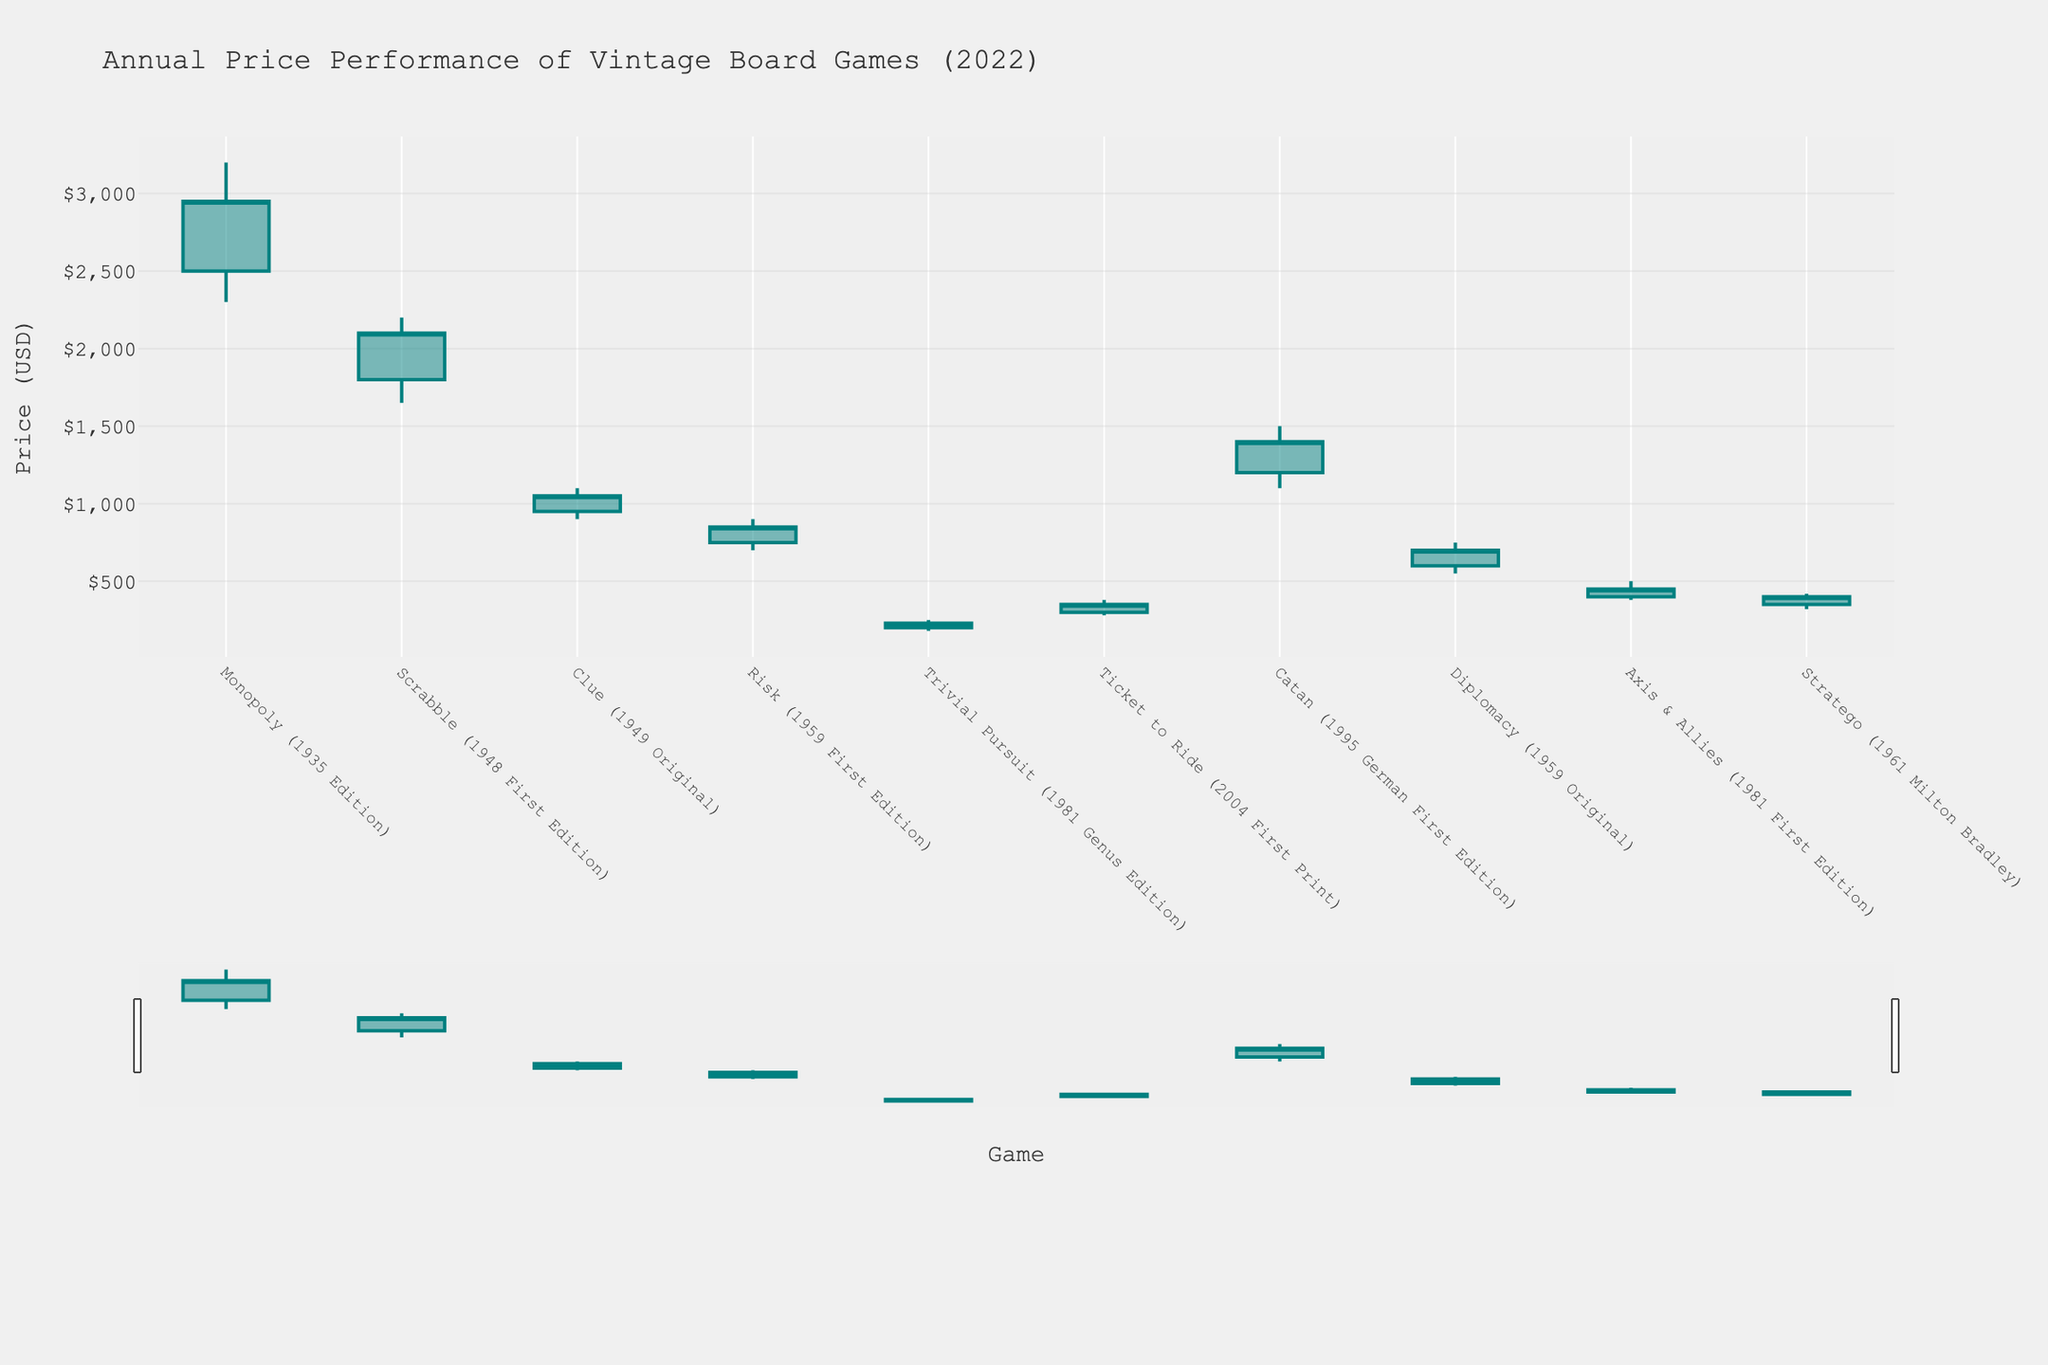What's the title of the figure? The title is located at the top of the figure, providing a concise description of what the data represents.
Answer: Annual Price Performance of Vintage Board Games (2022) How many board games are displayed in the figure? Count the number of distinct games listed on the x-axis.
Answer: 10 Which board game had the highest peak value in 2022? Locate the board game with the highest 'High' value by comparing peak values of all games.
Answer: Monopoly (1935 Edition) Which board game experienced the lowest value in 2022 and what was its lowest value? Find the game with the lowest 'Low' value by checking the 'Low' points of each game.
Answer: Trivial Pursuit (1981 Genus Edition), $180 What was the closing value of Catan (1995 German First Edition) in 2022? Identify Catan on the x-axis and refer to its 'Close' value.
Answer: $1400 Compare the opening and closing prices of Scrabble (1948 First Edition). Did the price increase or decrease? Check the 'Open' and 'Close' values for Scrabble and determine the difference.
Answer: Increased Which game had the smallest difference between its peak value and lowest value in 2022? For each game, calculate the difference between 'High' and 'Low' values and find the smallest difference.
Answer: Clue (1949 Original) What is the average closing value of all the board games displayed? Sum the 'Close' values of all games and divide by the number of games.
Answer: 1138.0 Among the games listed, which one had the highest closing price in 2022? Compare the 'Close' values of all games to identify the highest one.
Answer: Monopoly (1935 Edition) Did any board game have an opening value lower than its lowest value during the year? If so, name it. Examine if any game's 'Open' value is lower than its 'Low' value.
Answer: No 